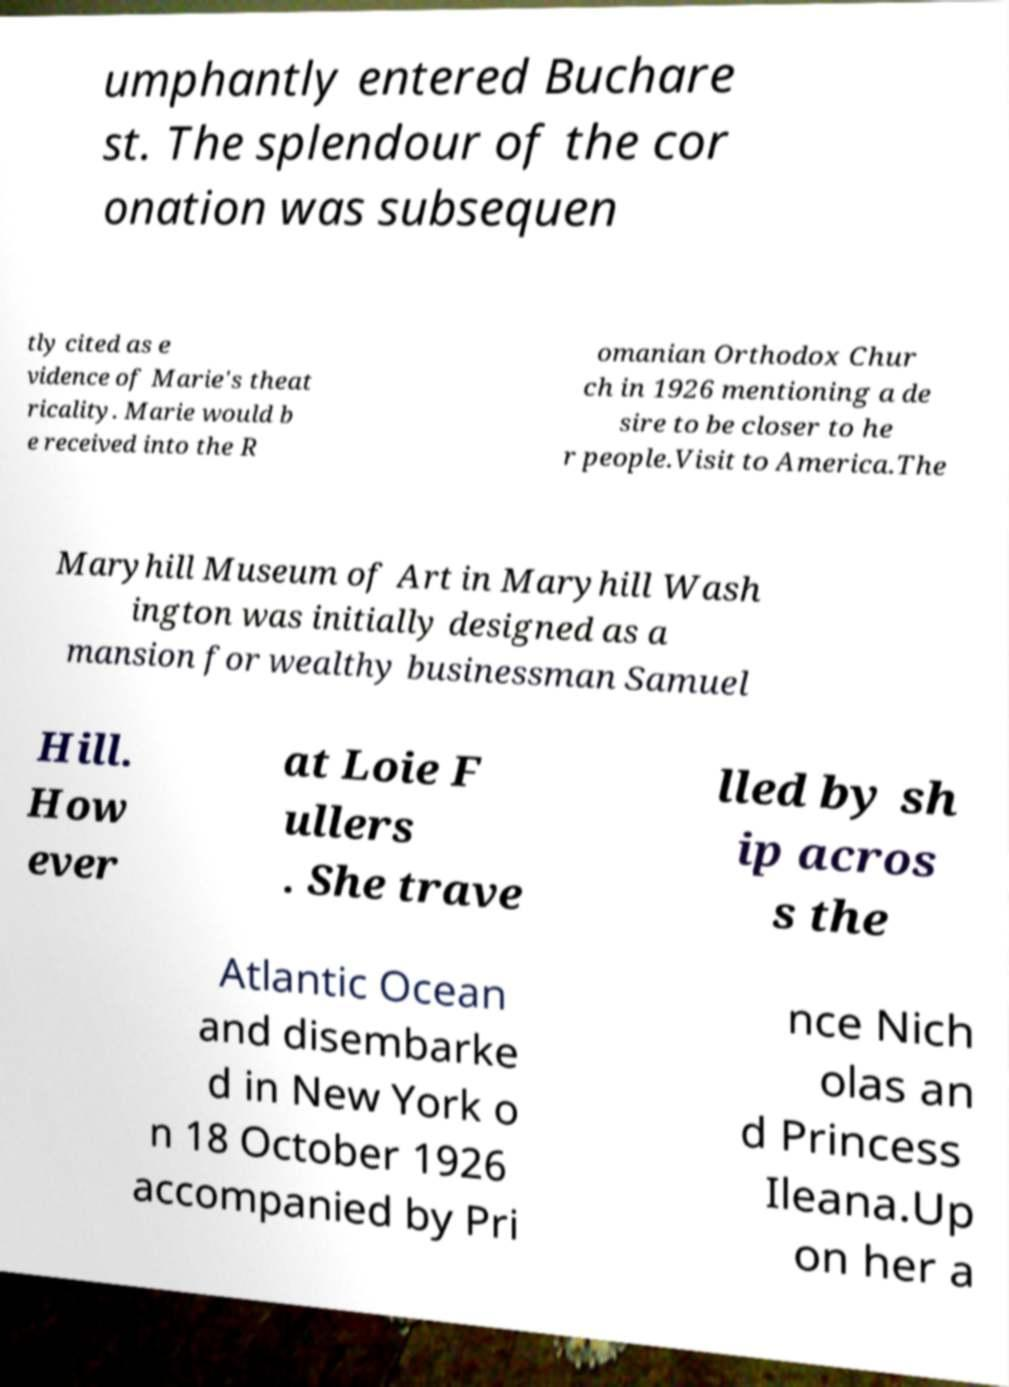I need the written content from this picture converted into text. Can you do that? umphantly entered Buchare st. The splendour of the cor onation was subsequen tly cited as e vidence of Marie's theat ricality. Marie would b e received into the R omanian Orthodox Chur ch in 1926 mentioning a de sire to be closer to he r people.Visit to America.The Maryhill Museum of Art in Maryhill Wash ington was initially designed as a mansion for wealthy businessman Samuel Hill. How ever at Loie F ullers . She trave lled by sh ip acros s the Atlantic Ocean and disembarke d in New York o n 18 October 1926 accompanied by Pri nce Nich olas an d Princess Ileana.Up on her a 